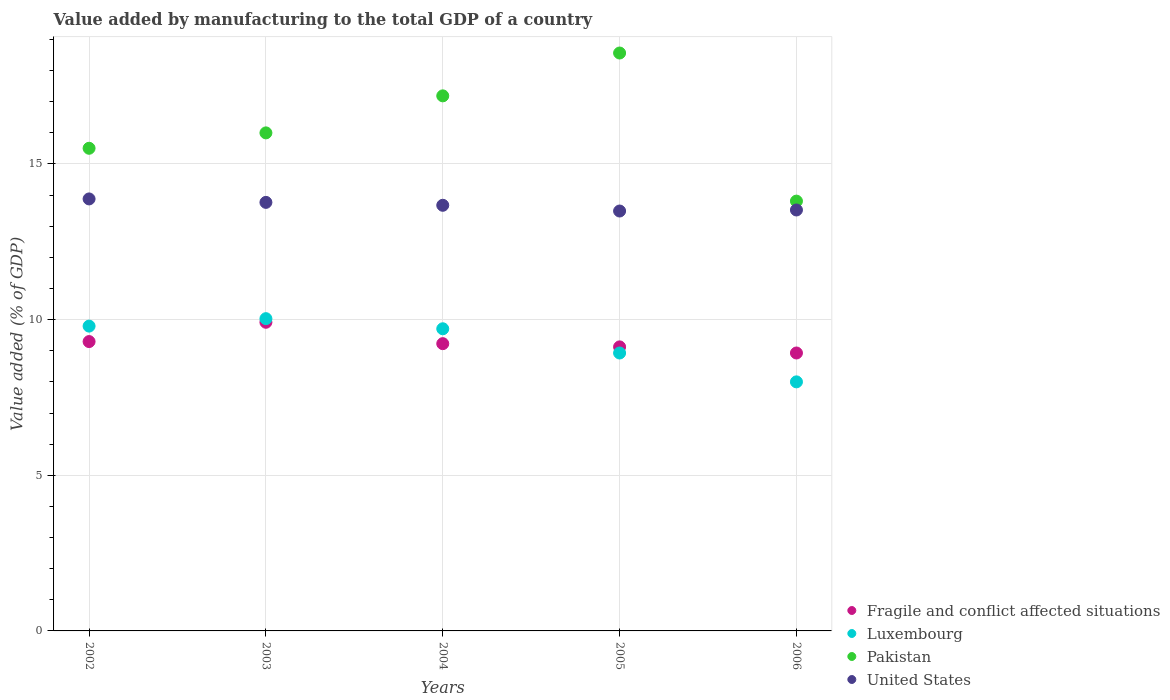How many different coloured dotlines are there?
Your answer should be compact. 4. What is the value added by manufacturing to the total GDP in Fragile and conflict affected situations in 2002?
Your response must be concise. 9.3. Across all years, what is the maximum value added by manufacturing to the total GDP in Fragile and conflict affected situations?
Your answer should be very brief. 9.92. Across all years, what is the minimum value added by manufacturing to the total GDP in Pakistan?
Your response must be concise. 13.81. In which year was the value added by manufacturing to the total GDP in United States minimum?
Ensure brevity in your answer.  2005. What is the total value added by manufacturing to the total GDP in Pakistan in the graph?
Make the answer very short. 81.06. What is the difference between the value added by manufacturing to the total GDP in Luxembourg in 2002 and that in 2003?
Make the answer very short. -0.24. What is the difference between the value added by manufacturing to the total GDP in Luxembourg in 2006 and the value added by manufacturing to the total GDP in United States in 2003?
Ensure brevity in your answer.  -5.77. What is the average value added by manufacturing to the total GDP in Fragile and conflict affected situations per year?
Your answer should be compact. 9.3. In the year 2002, what is the difference between the value added by manufacturing to the total GDP in Fragile and conflict affected situations and value added by manufacturing to the total GDP in Luxembourg?
Give a very brief answer. -0.5. In how many years, is the value added by manufacturing to the total GDP in Pakistan greater than 2 %?
Offer a very short reply. 5. What is the ratio of the value added by manufacturing to the total GDP in Pakistan in 2002 to that in 2003?
Your answer should be very brief. 0.97. Is the difference between the value added by manufacturing to the total GDP in Fragile and conflict affected situations in 2005 and 2006 greater than the difference between the value added by manufacturing to the total GDP in Luxembourg in 2005 and 2006?
Keep it short and to the point. No. What is the difference between the highest and the second highest value added by manufacturing to the total GDP in Luxembourg?
Your response must be concise. 0.24. What is the difference between the highest and the lowest value added by manufacturing to the total GDP in Pakistan?
Offer a terse response. 4.76. Is the sum of the value added by manufacturing to the total GDP in United States in 2003 and 2005 greater than the maximum value added by manufacturing to the total GDP in Fragile and conflict affected situations across all years?
Make the answer very short. Yes. How many dotlines are there?
Provide a short and direct response. 4. What is the difference between two consecutive major ticks on the Y-axis?
Make the answer very short. 5. Are the values on the major ticks of Y-axis written in scientific E-notation?
Your response must be concise. No. Where does the legend appear in the graph?
Your answer should be compact. Bottom right. How many legend labels are there?
Provide a succinct answer. 4. What is the title of the graph?
Provide a short and direct response. Value added by manufacturing to the total GDP of a country. What is the label or title of the X-axis?
Provide a succinct answer. Years. What is the label or title of the Y-axis?
Your answer should be compact. Value added (% of GDP). What is the Value added (% of GDP) of Fragile and conflict affected situations in 2002?
Your response must be concise. 9.3. What is the Value added (% of GDP) of Luxembourg in 2002?
Your answer should be very brief. 9.79. What is the Value added (% of GDP) of Pakistan in 2002?
Provide a short and direct response. 15.5. What is the Value added (% of GDP) in United States in 2002?
Offer a very short reply. 13.88. What is the Value added (% of GDP) in Fragile and conflict affected situations in 2003?
Offer a terse response. 9.92. What is the Value added (% of GDP) in Luxembourg in 2003?
Provide a short and direct response. 10.03. What is the Value added (% of GDP) in Pakistan in 2003?
Ensure brevity in your answer.  16. What is the Value added (% of GDP) in United States in 2003?
Provide a short and direct response. 13.77. What is the Value added (% of GDP) of Fragile and conflict affected situations in 2004?
Ensure brevity in your answer.  9.23. What is the Value added (% of GDP) of Luxembourg in 2004?
Give a very brief answer. 9.71. What is the Value added (% of GDP) of Pakistan in 2004?
Your response must be concise. 17.19. What is the Value added (% of GDP) of United States in 2004?
Provide a succinct answer. 13.67. What is the Value added (% of GDP) in Fragile and conflict affected situations in 2005?
Offer a terse response. 9.12. What is the Value added (% of GDP) in Luxembourg in 2005?
Keep it short and to the point. 8.93. What is the Value added (% of GDP) of Pakistan in 2005?
Give a very brief answer. 18.56. What is the Value added (% of GDP) of United States in 2005?
Your answer should be compact. 13.49. What is the Value added (% of GDP) in Fragile and conflict affected situations in 2006?
Your response must be concise. 8.93. What is the Value added (% of GDP) in Luxembourg in 2006?
Your response must be concise. 8. What is the Value added (% of GDP) in Pakistan in 2006?
Your response must be concise. 13.81. What is the Value added (% of GDP) in United States in 2006?
Your answer should be very brief. 13.52. Across all years, what is the maximum Value added (% of GDP) in Fragile and conflict affected situations?
Ensure brevity in your answer.  9.92. Across all years, what is the maximum Value added (% of GDP) of Luxembourg?
Your response must be concise. 10.03. Across all years, what is the maximum Value added (% of GDP) of Pakistan?
Offer a very short reply. 18.56. Across all years, what is the maximum Value added (% of GDP) of United States?
Provide a succinct answer. 13.88. Across all years, what is the minimum Value added (% of GDP) of Fragile and conflict affected situations?
Your answer should be very brief. 8.93. Across all years, what is the minimum Value added (% of GDP) of Luxembourg?
Ensure brevity in your answer.  8. Across all years, what is the minimum Value added (% of GDP) of Pakistan?
Your answer should be very brief. 13.81. Across all years, what is the minimum Value added (% of GDP) of United States?
Keep it short and to the point. 13.49. What is the total Value added (% of GDP) of Fragile and conflict affected situations in the graph?
Provide a short and direct response. 46.49. What is the total Value added (% of GDP) of Luxembourg in the graph?
Offer a terse response. 46.46. What is the total Value added (% of GDP) of Pakistan in the graph?
Keep it short and to the point. 81.06. What is the total Value added (% of GDP) in United States in the graph?
Your response must be concise. 68.33. What is the difference between the Value added (% of GDP) in Fragile and conflict affected situations in 2002 and that in 2003?
Make the answer very short. -0.62. What is the difference between the Value added (% of GDP) in Luxembourg in 2002 and that in 2003?
Provide a succinct answer. -0.24. What is the difference between the Value added (% of GDP) of Pakistan in 2002 and that in 2003?
Provide a succinct answer. -0.49. What is the difference between the Value added (% of GDP) of United States in 2002 and that in 2003?
Your answer should be very brief. 0.11. What is the difference between the Value added (% of GDP) of Fragile and conflict affected situations in 2002 and that in 2004?
Make the answer very short. 0.07. What is the difference between the Value added (% of GDP) in Luxembourg in 2002 and that in 2004?
Offer a very short reply. 0.09. What is the difference between the Value added (% of GDP) in Pakistan in 2002 and that in 2004?
Offer a very short reply. -1.68. What is the difference between the Value added (% of GDP) of United States in 2002 and that in 2004?
Keep it short and to the point. 0.2. What is the difference between the Value added (% of GDP) in Fragile and conflict affected situations in 2002 and that in 2005?
Ensure brevity in your answer.  0.17. What is the difference between the Value added (% of GDP) of Luxembourg in 2002 and that in 2005?
Your answer should be very brief. 0.86. What is the difference between the Value added (% of GDP) in Pakistan in 2002 and that in 2005?
Ensure brevity in your answer.  -3.06. What is the difference between the Value added (% of GDP) in United States in 2002 and that in 2005?
Offer a terse response. 0.39. What is the difference between the Value added (% of GDP) in Fragile and conflict affected situations in 2002 and that in 2006?
Keep it short and to the point. 0.37. What is the difference between the Value added (% of GDP) of Luxembourg in 2002 and that in 2006?
Provide a short and direct response. 1.79. What is the difference between the Value added (% of GDP) of Pakistan in 2002 and that in 2006?
Offer a very short reply. 1.7. What is the difference between the Value added (% of GDP) in United States in 2002 and that in 2006?
Give a very brief answer. 0.36. What is the difference between the Value added (% of GDP) of Fragile and conflict affected situations in 2003 and that in 2004?
Offer a very short reply. 0.69. What is the difference between the Value added (% of GDP) in Luxembourg in 2003 and that in 2004?
Ensure brevity in your answer.  0.32. What is the difference between the Value added (% of GDP) in Pakistan in 2003 and that in 2004?
Your response must be concise. -1.19. What is the difference between the Value added (% of GDP) of United States in 2003 and that in 2004?
Make the answer very short. 0.09. What is the difference between the Value added (% of GDP) of Fragile and conflict affected situations in 2003 and that in 2005?
Give a very brief answer. 0.79. What is the difference between the Value added (% of GDP) in Luxembourg in 2003 and that in 2005?
Your answer should be very brief. 1.1. What is the difference between the Value added (% of GDP) in Pakistan in 2003 and that in 2005?
Give a very brief answer. -2.57. What is the difference between the Value added (% of GDP) of United States in 2003 and that in 2005?
Ensure brevity in your answer.  0.28. What is the difference between the Value added (% of GDP) of Fragile and conflict affected situations in 2003 and that in 2006?
Keep it short and to the point. 0.99. What is the difference between the Value added (% of GDP) in Luxembourg in 2003 and that in 2006?
Offer a terse response. 2.03. What is the difference between the Value added (% of GDP) of Pakistan in 2003 and that in 2006?
Ensure brevity in your answer.  2.19. What is the difference between the Value added (% of GDP) in United States in 2003 and that in 2006?
Offer a terse response. 0.24. What is the difference between the Value added (% of GDP) in Fragile and conflict affected situations in 2004 and that in 2005?
Make the answer very short. 0.1. What is the difference between the Value added (% of GDP) of Luxembourg in 2004 and that in 2005?
Your answer should be compact. 0.78. What is the difference between the Value added (% of GDP) of Pakistan in 2004 and that in 2005?
Your answer should be very brief. -1.38. What is the difference between the Value added (% of GDP) of United States in 2004 and that in 2005?
Offer a terse response. 0.18. What is the difference between the Value added (% of GDP) of Fragile and conflict affected situations in 2004 and that in 2006?
Offer a terse response. 0.3. What is the difference between the Value added (% of GDP) of Luxembourg in 2004 and that in 2006?
Provide a short and direct response. 1.71. What is the difference between the Value added (% of GDP) in Pakistan in 2004 and that in 2006?
Give a very brief answer. 3.38. What is the difference between the Value added (% of GDP) in United States in 2004 and that in 2006?
Offer a terse response. 0.15. What is the difference between the Value added (% of GDP) of Fragile and conflict affected situations in 2005 and that in 2006?
Your response must be concise. 0.2. What is the difference between the Value added (% of GDP) of Luxembourg in 2005 and that in 2006?
Ensure brevity in your answer.  0.93. What is the difference between the Value added (% of GDP) of Pakistan in 2005 and that in 2006?
Provide a short and direct response. 4.76. What is the difference between the Value added (% of GDP) of United States in 2005 and that in 2006?
Offer a terse response. -0.03. What is the difference between the Value added (% of GDP) of Fragile and conflict affected situations in 2002 and the Value added (% of GDP) of Luxembourg in 2003?
Keep it short and to the point. -0.74. What is the difference between the Value added (% of GDP) in Fragile and conflict affected situations in 2002 and the Value added (% of GDP) in Pakistan in 2003?
Make the answer very short. -6.7. What is the difference between the Value added (% of GDP) in Fragile and conflict affected situations in 2002 and the Value added (% of GDP) in United States in 2003?
Offer a very short reply. -4.47. What is the difference between the Value added (% of GDP) in Luxembourg in 2002 and the Value added (% of GDP) in Pakistan in 2003?
Your answer should be compact. -6.21. What is the difference between the Value added (% of GDP) in Luxembourg in 2002 and the Value added (% of GDP) in United States in 2003?
Give a very brief answer. -3.97. What is the difference between the Value added (% of GDP) of Pakistan in 2002 and the Value added (% of GDP) of United States in 2003?
Provide a short and direct response. 1.74. What is the difference between the Value added (% of GDP) in Fragile and conflict affected situations in 2002 and the Value added (% of GDP) in Luxembourg in 2004?
Give a very brief answer. -0.41. What is the difference between the Value added (% of GDP) of Fragile and conflict affected situations in 2002 and the Value added (% of GDP) of Pakistan in 2004?
Provide a succinct answer. -7.89. What is the difference between the Value added (% of GDP) in Fragile and conflict affected situations in 2002 and the Value added (% of GDP) in United States in 2004?
Make the answer very short. -4.38. What is the difference between the Value added (% of GDP) of Luxembourg in 2002 and the Value added (% of GDP) of Pakistan in 2004?
Give a very brief answer. -7.4. What is the difference between the Value added (% of GDP) in Luxembourg in 2002 and the Value added (% of GDP) in United States in 2004?
Keep it short and to the point. -3.88. What is the difference between the Value added (% of GDP) in Pakistan in 2002 and the Value added (% of GDP) in United States in 2004?
Offer a terse response. 1.83. What is the difference between the Value added (% of GDP) of Fragile and conflict affected situations in 2002 and the Value added (% of GDP) of Luxembourg in 2005?
Give a very brief answer. 0.37. What is the difference between the Value added (% of GDP) in Fragile and conflict affected situations in 2002 and the Value added (% of GDP) in Pakistan in 2005?
Your answer should be compact. -9.27. What is the difference between the Value added (% of GDP) of Fragile and conflict affected situations in 2002 and the Value added (% of GDP) of United States in 2005?
Provide a succinct answer. -4.19. What is the difference between the Value added (% of GDP) of Luxembourg in 2002 and the Value added (% of GDP) of Pakistan in 2005?
Offer a terse response. -8.77. What is the difference between the Value added (% of GDP) in Luxembourg in 2002 and the Value added (% of GDP) in United States in 2005?
Your response must be concise. -3.7. What is the difference between the Value added (% of GDP) of Pakistan in 2002 and the Value added (% of GDP) of United States in 2005?
Your answer should be very brief. 2.02. What is the difference between the Value added (% of GDP) in Fragile and conflict affected situations in 2002 and the Value added (% of GDP) in Luxembourg in 2006?
Give a very brief answer. 1.29. What is the difference between the Value added (% of GDP) of Fragile and conflict affected situations in 2002 and the Value added (% of GDP) of Pakistan in 2006?
Ensure brevity in your answer.  -4.51. What is the difference between the Value added (% of GDP) of Fragile and conflict affected situations in 2002 and the Value added (% of GDP) of United States in 2006?
Your response must be concise. -4.23. What is the difference between the Value added (% of GDP) of Luxembourg in 2002 and the Value added (% of GDP) of Pakistan in 2006?
Provide a short and direct response. -4.02. What is the difference between the Value added (% of GDP) in Luxembourg in 2002 and the Value added (% of GDP) in United States in 2006?
Keep it short and to the point. -3.73. What is the difference between the Value added (% of GDP) in Pakistan in 2002 and the Value added (% of GDP) in United States in 2006?
Offer a terse response. 1.98. What is the difference between the Value added (% of GDP) of Fragile and conflict affected situations in 2003 and the Value added (% of GDP) of Luxembourg in 2004?
Offer a very short reply. 0.21. What is the difference between the Value added (% of GDP) in Fragile and conflict affected situations in 2003 and the Value added (% of GDP) in Pakistan in 2004?
Provide a short and direct response. -7.27. What is the difference between the Value added (% of GDP) of Fragile and conflict affected situations in 2003 and the Value added (% of GDP) of United States in 2004?
Offer a very short reply. -3.76. What is the difference between the Value added (% of GDP) of Luxembourg in 2003 and the Value added (% of GDP) of Pakistan in 2004?
Your response must be concise. -7.16. What is the difference between the Value added (% of GDP) of Luxembourg in 2003 and the Value added (% of GDP) of United States in 2004?
Offer a very short reply. -3.64. What is the difference between the Value added (% of GDP) in Pakistan in 2003 and the Value added (% of GDP) in United States in 2004?
Your answer should be very brief. 2.33. What is the difference between the Value added (% of GDP) of Fragile and conflict affected situations in 2003 and the Value added (% of GDP) of Luxembourg in 2005?
Your answer should be very brief. 0.99. What is the difference between the Value added (% of GDP) of Fragile and conflict affected situations in 2003 and the Value added (% of GDP) of Pakistan in 2005?
Keep it short and to the point. -8.65. What is the difference between the Value added (% of GDP) of Fragile and conflict affected situations in 2003 and the Value added (% of GDP) of United States in 2005?
Offer a terse response. -3.57. What is the difference between the Value added (% of GDP) of Luxembourg in 2003 and the Value added (% of GDP) of Pakistan in 2005?
Offer a terse response. -8.53. What is the difference between the Value added (% of GDP) in Luxembourg in 2003 and the Value added (% of GDP) in United States in 2005?
Ensure brevity in your answer.  -3.46. What is the difference between the Value added (% of GDP) of Pakistan in 2003 and the Value added (% of GDP) of United States in 2005?
Your answer should be compact. 2.51. What is the difference between the Value added (% of GDP) of Fragile and conflict affected situations in 2003 and the Value added (% of GDP) of Luxembourg in 2006?
Provide a short and direct response. 1.91. What is the difference between the Value added (% of GDP) of Fragile and conflict affected situations in 2003 and the Value added (% of GDP) of Pakistan in 2006?
Offer a terse response. -3.89. What is the difference between the Value added (% of GDP) in Fragile and conflict affected situations in 2003 and the Value added (% of GDP) in United States in 2006?
Your answer should be very brief. -3.61. What is the difference between the Value added (% of GDP) in Luxembourg in 2003 and the Value added (% of GDP) in Pakistan in 2006?
Provide a short and direct response. -3.78. What is the difference between the Value added (% of GDP) of Luxembourg in 2003 and the Value added (% of GDP) of United States in 2006?
Ensure brevity in your answer.  -3.49. What is the difference between the Value added (% of GDP) in Pakistan in 2003 and the Value added (% of GDP) in United States in 2006?
Provide a succinct answer. 2.48. What is the difference between the Value added (% of GDP) in Fragile and conflict affected situations in 2004 and the Value added (% of GDP) in Luxembourg in 2005?
Your answer should be compact. 0.3. What is the difference between the Value added (% of GDP) in Fragile and conflict affected situations in 2004 and the Value added (% of GDP) in Pakistan in 2005?
Your answer should be very brief. -9.34. What is the difference between the Value added (% of GDP) of Fragile and conflict affected situations in 2004 and the Value added (% of GDP) of United States in 2005?
Keep it short and to the point. -4.26. What is the difference between the Value added (% of GDP) of Luxembourg in 2004 and the Value added (% of GDP) of Pakistan in 2005?
Provide a short and direct response. -8.86. What is the difference between the Value added (% of GDP) in Luxembourg in 2004 and the Value added (% of GDP) in United States in 2005?
Provide a succinct answer. -3.78. What is the difference between the Value added (% of GDP) of Pakistan in 2004 and the Value added (% of GDP) of United States in 2005?
Offer a very short reply. 3.7. What is the difference between the Value added (% of GDP) in Fragile and conflict affected situations in 2004 and the Value added (% of GDP) in Luxembourg in 2006?
Ensure brevity in your answer.  1.23. What is the difference between the Value added (% of GDP) in Fragile and conflict affected situations in 2004 and the Value added (% of GDP) in Pakistan in 2006?
Give a very brief answer. -4.58. What is the difference between the Value added (% of GDP) in Fragile and conflict affected situations in 2004 and the Value added (% of GDP) in United States in 2006?
Give a very brief answer. -4.29. What is the difference between the Value added (% of GDP) of Luxembourg in 2004 and the Value added (% of GDP) of Pakistan in 2006?
Keep it short and to the point. -4.1. What is the difference between the Value added (% of GDP) in Luxembourg in 2004 and the Value added (% of GDP) in United States in 2006?
Provide a short and direct response. -3.82. What is the difference between the Value added (% of GDP) in Pakistan in 2004 and the Value added (% of GDP) in United States in 2006?
Provide a succinct answer. 3.67. What is the difference between the Value added (% of GDP) of Fragile and conflict affected situations in 2005 and the Value added (% of GDP) of Luxembourg in 2006?
Your answer should be compact. 1.12. What is the difference between the Value added (% of GDP) of Fragile and conflict affected situations in 2005 and the Value added (% of GDP) of Pakistan in 2006?
Offer a terse response. -4.68. What is the difference between the Value added (% of GDP) in Fragile and conflict affected situations in 2005 and the Value added (% of GDP) in United States in 2006?
Offer a very short reply. -4.4. What is the difference between the Value added (% of GDP) in Luxembourg in 2005 and the Value added (% of GDP) in Pakistan in 2006?
Ensure brevity in your answer.  -4.88. What is the difference between the Value added (% of GDP) of Luxembourg in 2005 and the Value added (% of GDP) of United States in 2006?
Your answer should be very brief. -4.59. What is the difference between the Value added (% of GDP) in Pakistan in 2005 and the Value added (% of GDP) in United States in 2006?
Your response must be concise. 5.04. What is the average Value added (% of GDP) in Fragile and conflict affected situations per year?
Provide a short and direct response. 9.3. What is the average Value added (% of GDP) in Luxembourg per year?
Give a very brief answer. 9.29. What is the average Value added (% of GDP) of Pakistan per year?
Provide a short and direct response. 16.21. What is the average Value added (% of GDP) in United States per year?
Offer a terse response. 13.67. In the year 2002, what is the difference between the Value added (% of GDP) of Fragile and conflict affected situations and Value added (% of GDP) of Luxembourg?
Provide a succinct answer. -0.5. In the year 2002, what is the difference between the Value added (% of GDP) of Fragile and conflict affected situations and Value added (% of GDP) of Pakistan?
Provide a short and direct response. -6.21. In the year 2002, what is the difference between the Value added (% of GDP) of Fragile and conflict affected situations and Value added (% of GDP) of United States?
Provide a short and direct response. -4.58. In the year 2002, what is the difference between the Value added (% of GDP) in Luxembourg and Value added (% of GDP) in Pakistan?
Provide a short and direct response. -5.71. In the year 2002, what is the difference between the Value added (% of GDP) of Luxembourg and Value added (% of GDP) of United States?
Your answer should be very brief. -4.09. In the year 2002, what is the difference between the Value added (% of GDP) of Pakistan and Value added (% of GDP) of United States?
Ensure brevity in your answer.  1.63. In the year 2003, what is the difference between the Value added (% of GDP) in Fragile and conflict affected situations and Value added (% of GDP) in Luxembourg?
Offer a terse response. -0.12. In the year 2003, what is the difference between the Value added (% of GDP) of Fragile and conflict affected situations and Value added (% of GDP) of Pakistan?
Give a very brief answer. -6.08. In the year 2003, what is the difference between the Value added (% of GDP) of Fragile and conflict affected situations and Value added (% of GDP) of United States?
Your answer should be very brief. -3.85. In the year 2003, what is the difference between the Value added (% of GDP) of Luxembourg and Value added (% of GDP) of Pakistan?
Keep it short and to the point. -5.97. In the year 2003, what is the difference between the Value added (% of GDP) in Luxembourg and Value added (% of GDP) in United States?
Keep it short and to the point. -3.74. In the year 2003, what is the difference between the Value added (% of GDP) in Pakistan and Value added (% of GDP) in United States?
Ensure brevity in your answer.  2.23. In the year 2004, what is the difference between the Value added (% of GDP) in Fragile and conflict affected situations and Value added (% of GDP) in Luxembourg?
Keep it short and to the point. -0.48. In the year 2004, what is the difference between the Value added (% of GDP) in Fragile and conflict affected situations and Value added (% of GDP) in Pakistan?
Offer a very short reply. -7.96. In the year 2004, what is the difference between the Value added (% of GDP) in Fragile and conflict affected situations and Value added (% of GDP) in United States?
Keep it short and to the point. -4.45. In the year 2004, what is the difference between the Value added (% of GDP) of Luxembourg and Value added (% of GDP) of Pakistan?
Provide a succinct answer. -7.48. In the year 2004, what is the difference between the Value added (% of GDP) of Luxembourg and Value added (% of GDP) of United States?
Your answer should be very brief. -3.97. In the year 2004, what is the difference between the Value added (% of GDP) in Pakistan and Value added (% of GDP) in United States?
Keep it short and to the point. 3.52. In the year 2005, what is the difference between the Value added (% of GDP) in Fragile and conflict affected situations and Value added (% of GDP) in Luxembourg?
Offer a terse response. 0.2. In the year 2005, what is the difference between the Value added (% of GDP) of Fragile and conflict affected situations and Value added (% of GDP) of Pakistan?
Make the answer very short. -9.44. In the year 2005, what is the difference between the Value added (% of GDP) of Fragile and conflict affected situations and Value added (% of GDP) of United States?
Offer a terse response. -4.36. In the year 2005, what is the difference between the Value added (% of GDP) in Luxembourg and Value added (% of GDP) in Pakistan?
Offer a terse response. -9.64. In the year 2005, what is the difference between the Value added (% of GDP) in Luxembourg and Value added (% of GDP) in United States?
Ensure brevity in your answer.  -4.56. In the year 2005, what is the difference between the Value added (% of GDP) of Pakistan and Value added (% of GDP) of United States?
Make the answer very short. 5.08. In the year 2006, what is the difference between the Value added (% of GDP) in Fragile and conflict affected situations and Value added (% of GDP) in Luxembourg?
Make the answer very short. 0.93. In the year 2006, what is the difference between the Value added (% of GDP) of Fragile and conflict affected situations and Value added (% of GDP) of Pakistan?
Your answer should be compact. -4.88. In the year 2006, what is the difference between the Value added (% of GDP) of Fragile and conflict affected situations and Value added (% of GDP) of United States?
Offer a terse response. -4.59. In the year 2006, what is the difference between the Value added (% of GDP) in Luxembourg and Value added (% of GDP) in Pakistan?
Ensure brevity in your answer.  -5.81. In the year 2006, what is the difference between the Value added (% of GDP) in Luxembourg and Value added (% of GDP) in United States?
Your response must be concise. -5.52. In the year 2006, what is the difference between the Value added (% of GDP) of Pakistan and Value added (% of GDP) of United States?
Ensure brevity in your answer.  0.28. What is the ratio of the Value added (% of GDP) in Luxembourg in 2002 to that in 2003?
Keep it short and to the point. 0.98. What is the ratio of the Value added (% of GDP) of Pakistan in 2002 to that in 2003?
Your answer should be very brief. 0.97. What is the ratio of the Value added (% of GDP) of United States in 2002 to that in 2003?
Your response must be concise. 1.01. What is the ratio of the Value added (% of GDP) of Fragile and conflict affected situations in 2002 to that in 2004?
Ensure brevity in your answer.  1.01. What is the ratio of the Value added (% of GDP) of Luxembourg in 2002 to that in 2004?
Make the answer very short. 1.01. What is the ratio of the Value added (% of GDP) of Pakistan in 2002 to that in 2004?
Provide a succinct answer. 0.9. What is the ratio of the Value added (% of GDP) in Fragile and conflict affected situations in 2002 to that in 2005?
Your response must be concise. 1.02. What is the ratio of the Value added (% of GDP) in Luxembourg in 2002 to that in 2005?
Make the answer very short. 1.1. What is the ratio of the Value added (% of GDP) in Pakistan in 2002 to that in 2005?
Offer a terse response. 0.84. What is the ratio of the Value added (% of GDP) of United States in 2002 to that in 2005?
Your response must be concise. 1.03. What is the ratio of the Value added (% of GDP) in Fragile and conflict affected situations in 2002 to that in 2006?
Keep it short and to the point. 1.04. What is the ratio of the Value added (% of GDP) of Luxembourg in 2002 to that in 2006?
Offer a terse response. 1.22. What is the ratio of the Value added (% of GDP) in Pakistan in 2002 to that in 2006?
Your answer should be compact. 1.12. What is the ratio of the Value added (% of GDP) of United States in 2002 to that in 2006?
Your response must be concise. 1.03. What is the ratio of the Value added (% of GDP) in Fragile and conflict affected situations in 2003 to that in 2004?
Your response must be concise. 1.07. What is the ratio of the Value added (% of GDP) of Luxembourg in 2003 to that in 2004?
Your answer should be compact. 1.03. What is the ratio of the Value added (% of GDP) of Pakistan in 2003 to that in 2004?
Offer a very short reply. 0.93. What is the ratio of the Value added (% of GDP) in United States in 2003 to that in 2004?
Offer a very short reply. 1.01. What is the ratio of the Value added (% of GDP) in Fragile and conflict affected situations in 2003 to that in 2005?
Offer a very short reply. 1.09. What is the ratio of the Value added (% of GDP) of Luxembourg in 2003 to that in 2005?
Provide a succinct answer. 1.12. What is the ratio of the Value added (% of GDP) of Pakistan in 2003 to that in 2005?
Offer a very short reply. 0.86. What is the ratio of the Value added (% of GDP) in United States in 2003 to that in 2005?
Your response must be concise. 1.02. What is the ratio of the Value added (% of GDP) in Fragile and conflict affected situations in 2003 to that in 2006?
Keep it short and to the point. 1.11. What is the ratio of the Value added (% of GDP) of Luxembourg in 2003 to that in 2006?
Keep it short and to the point. 1.25. What is the ratio of the Value added (% of GDP) in Pakistan in 2003 to that in 2006?
Make the answer very short. 1.16. What is the ratio of the Value added (% of GDP) in United States in 2003 to that in 2006?
Give a very brief answer. 1.02. What is the ratio of the Value added (% of GDP) of Fragile and conflict affected situations in 2004 to that in 2005?
Make the answer very short. 1.01. What is the ratio of the Value added (% of GDP) in Luxembourg in 2004 to that in 2005?
Offer a very short reply. 1.09. What is the ratio of the Value added (% of GDP) of Pakistan in 2004 to that in 2005?
Offer a very short reply. 0.93. What is the ratio of the Value added (% of GDP) of United States in 2004 to that in 2005?
Your answer should be compact. 1.01. What is the ratio of the Value added (% of GDP) of Fragile and conflict affected situations in 2004 to that in 2006?
Offer a very short reply. 1.03. What is the ratio of the Value added (% of GDP) of Luxembourg in 2004 to that in 2006?
Provide a succinct answer. 1.21. What is the ratio of the Value added (% of GDP) in Pakistan in 2004 to that in 2006?
Your answer should be very brief. 1.24. What is the ratio of the Value added (% of GDP) in United States in 2004 to that in 2006?
Keep it short and to the point. 1.01. What is the ratio of the Value added (% of GDP) of Luxembourg in 2005 to that in 2006?
Ensure brevity in your answer.  1.12. What is the ratio of the Value added (% of GDP) in Pakistan in 2005 to that in 2006?
Keep it short and to the point. 1.34. What is the difference between the highest and the second highest Value added (% of GDP) of Fragile and conflict affected situations?
Give a very brief answer. 0.62. What is the difference between the highest and the second highest Value added (% of GDP) of Luxembourg?
Keep it short and to the point. 0.24. What is the difference between the highest and the second highest Value added (% of GDP) of Pakistan?
Your answer should be compact. 1.38. What is the difference between the highest and the second highest Value added (% of GDP) in United States?
Your response must be concise. 0.11. What is the difference between the highest and the lowest Value added (% of GDP) in Luxembourg?
Ensure brevity in your answer.  2.03. What is the difference between the highest and the lowest Value added (% of GDP) in Pakistan?
Make the answer very short. 4.76. What is the difference between the highest and the lowest Value added (% of GDP) of United States?
Make the answer very short. 0.39. 